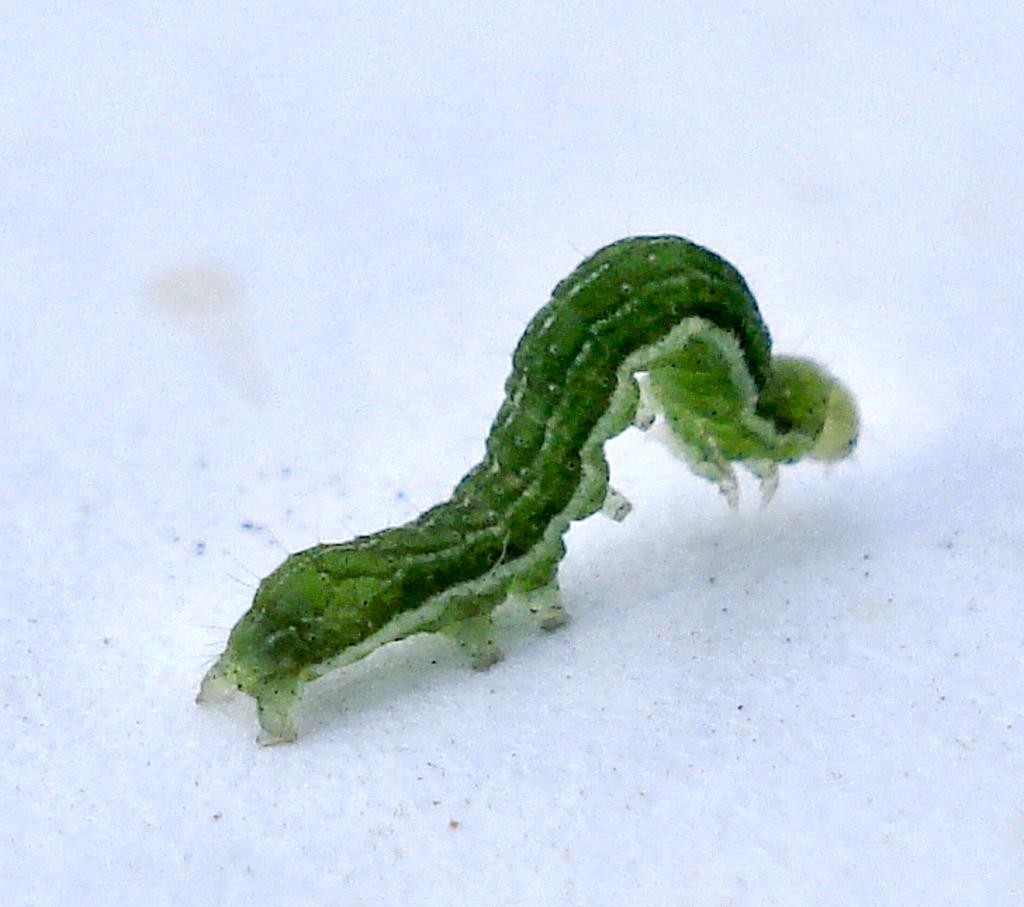What type of animal is present in the image? There is a caterpillar in the image. What color is the caterpillar? The caterpillar is green in color. What type of bird can be seen flying in the image? There is no bird present in the image; it only features a green caterpillar. 